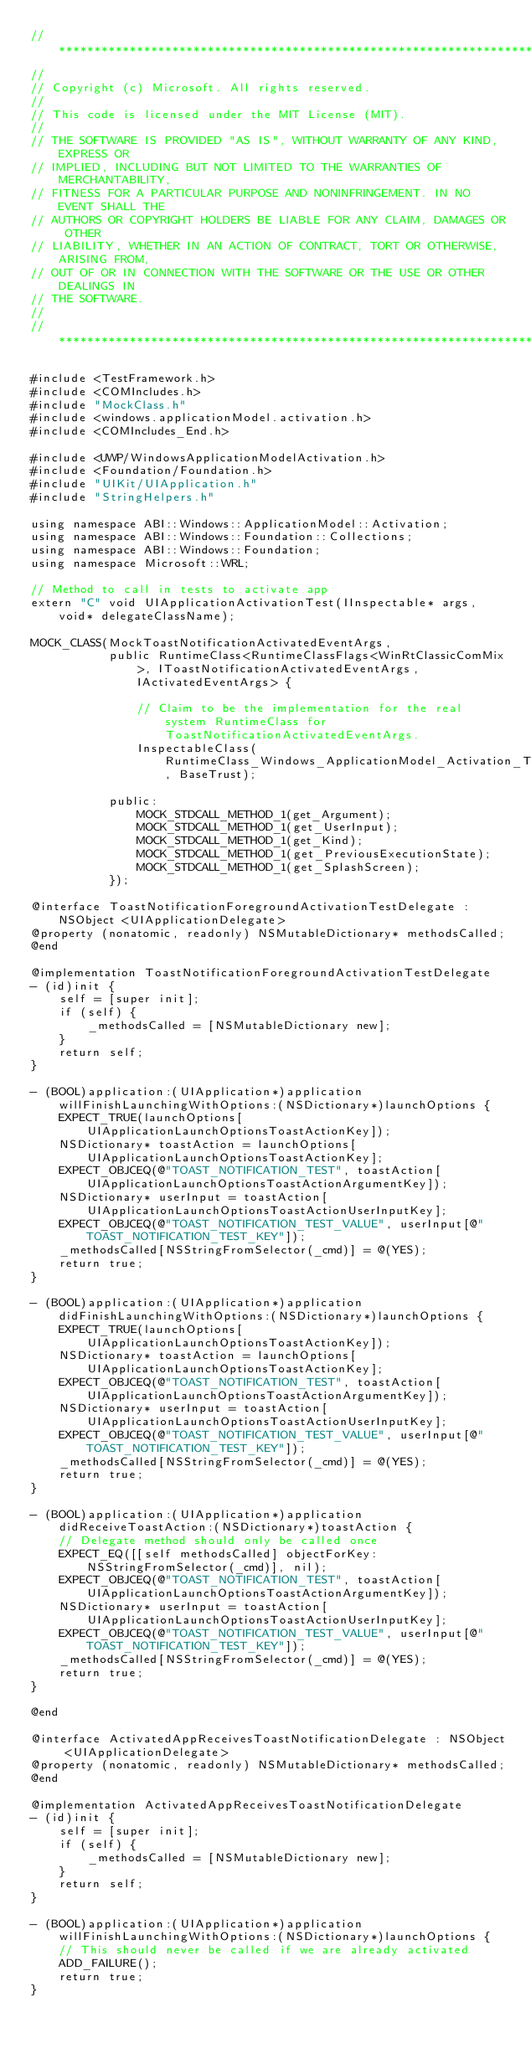<code> <loc_0><loc_0><loc_500><loc_500><_ObjectiveC_>//******************************************************************************
//
// Copyright (c) Microsoft. All rights reserved.
//
// This code is licensed under the MIT License (MIT).
//
// THE SOFTWARE IS PROVIDED "AS IS", WITHOUT WARRANTY OF ANY KIND, EXPRESS OR
// IMPLIED, INCLUDING BUT NOT LIMITED TO THE WARRANTIES OF MERCHANTABILITY,
// FITNESS FOR A PARTICULAR PURPOSE AND NONINFRINGEMENT. IN NO EVENT SHALL THE
// AUTHORS OR COPYRIGHT HOLDERS BE LIABLE FOR ANY CLAIM, DAMAGES OR OTHER
// LIABILITY, WHETHER IN AN ACTION OF CONTRACT, TORT OR OTHERWISE, ARISING FROM,
// OUT OF OR IN CONNECTION WITH THE SOFTWARE OR THE USE OR OTHER DEALINGS IN
// THE SOFTWARE.
//
//******************************************************************************

#include <TestFramework.h>
#include <COMIncludes.h>
#include "MockClass.h"
#include <windows.applicationModel.activation.h>
#include <COMIncludes_End.h>

#include <UWP/WindowsApplicationModelActivation.h>
#include <Foundation/Foundation.h>
#include "UIKit/UIApplication.h"
#include "StringHelpers.h"

using namespace ABI::Windows::ApplicationModel::Activation;
using namespace ABI::Windows::Foundation::Collections;
using namespace ABI::Windows::Foundation;
using namespace Microsoft::WRL;

// Method to call in tests to activate app
extern "C" void UIApplicationActivationTest(IInspectable* args, void* delegateClassName);

MOCK_CLASS(MockToastNotificationActivatedEventArgs,
           public RuntimeClass<RuntimeClassFlags<WinRtClassicComMix>, IToastNotificationActivatedEventArgs, IActivatedEventArgs> {

               // Claim to be the implementation for the real system RuntimeClass for ToastNotificationActivatedEventArgs.
               InspectableClass(RuntimeClass_Windows_ApplicationModel_Activation_ToastNotificationActivatedEventArgs, BaseTrust);

           public:
               MOCK_STDCALL_METHOD_1(get_Argument);
               MOCK_STDCALL_METHOD_1(get_UserInput);
               MOCK_STDCALL_METHOD_1(get_Kind);
               MOCK_STDCALL_METHOD_1(get_PreviousExecutionState);
               MOCK_STDCALL_METHOD_1(get_SplashScreen);
           });

@interface ToastNotificationForegroundActivationTestDelegate : NSObject <UIApplicationDelegate>
@property (nonatomic, readonly) NSMutableDictionary* methodsCalled;
@end

@implementation ToastNotificationForegroundActivationTestDelegate
- (id)init {
    self = [super init];
    if (self) {
        _methodsCalled = [NSMutableDictionary new];
    }
    return self;
}

- (BOOL)application:(UIApplication*)application willFinishLaunchingWithOptions:(NSDictionary*)launchOptions {
    EXPECT_TRUE(launchOptions[UIApplicationLaunchOptionsToastActionKey]);
    NSDictionary* toastAction = launchOptions[UIApplicationLaunchOptionsToastActionKey];
    EXPECT_OBJCEQ(@"TOAST_NOTIFICATION_TEST", toastAction[UIApplicationLaunchOptionsToastActionArgumentKey]);
    NSDictionary* userInput = toastAction[UIApplicationLaunchOptionsToastActionUserInputKey];
    EXPECT_OBJCEQ(@"TOAST_NOTIFICATION_TEST_VALUE", userInput[@"TOAST_NOTIFICATION_TEST_KEY"]);
    _methodsCalled[NSStringFromSelector(_cmd)] = @(YES);
    return true;
}

- (BOOL)application:(UIApplication*)application didFinishLaunchingWithOptions:(NSDictionary*)launchOptions {
    EXPECT_TRUE(launchOptions[UIApplicationLaunchOptionsToastActionKey]);
    NSDictionary* toastAction = launchOptions[UIApplicationLaunchOptionsToastActionKey];
    EXPECT_OBJCEQ(@"TOAST_NOTIFICATION_TEST", toastAction[UIApplicationLaunchOptionsToastActionArgumentKey]);
    NSDictionary* userInput = toastAction[UIApplicationLaunchOptionsToastActionUserInputKey];
    EXPECT_OBJCEQ(@"TOAST_NOTIFICATION_TEST_VALUE", userInput[@"TOAST_NOTIFICATION_TEST_KEY"]);
    _methodsCalled[NSStringFromSelector(_cmd)] = @(YES);
    return true;
}

- (BOOL)application:(UIApplication*)application didReceiveToastAction:(NSDictionary*)toastAction {
    // Delegate method should only be called once
    EXPECT_EQ([[self methodsCalled] objectForKey:NSStringFromSelector(_cmd)], nil);
    EXPECT_OBJCEQ(@"TOAST_NOTIFICATION_TEST", toastAction[UIApplicationLaunchOptionsToastActionArgumentKey]);
    NSDictionary* userInput = toastAction[UIApplicationLaunchOptionsToastActionUserInputKey];
    EXPECT_OBJCEQ(@"TOAST_NOTIFICATION_TEST_VALUE", userInput[@"TOAST_NOTIFICATION_TEST_KEY"]);
    _methodsCalled[NSStringFromSelector(_cmd)] = @(YES);
    return true;
}

@end

@interface ActivatedAppReceivesToastNotificationDelegate : NSObject <UIApplicationDelegate>
@property (nonatomic, readonly) NSMutableDictionary* methodsCalled;
@end

@implementation ActivatedAppReceivesToastNotificationDelegate
- (id)init {
    self = [super init];
    if (self) {
        _methodsCalled = [NSMutableDictionary new];
    }
    return self;
}

- (BOOL)application:(UIApplication*)application willFinishLaunchingWithOptions:(NSDictionary*)launchOptions {
    // This should never be called if we are already activated
    ADD_FAILURE();
    return true;
}
</code> 